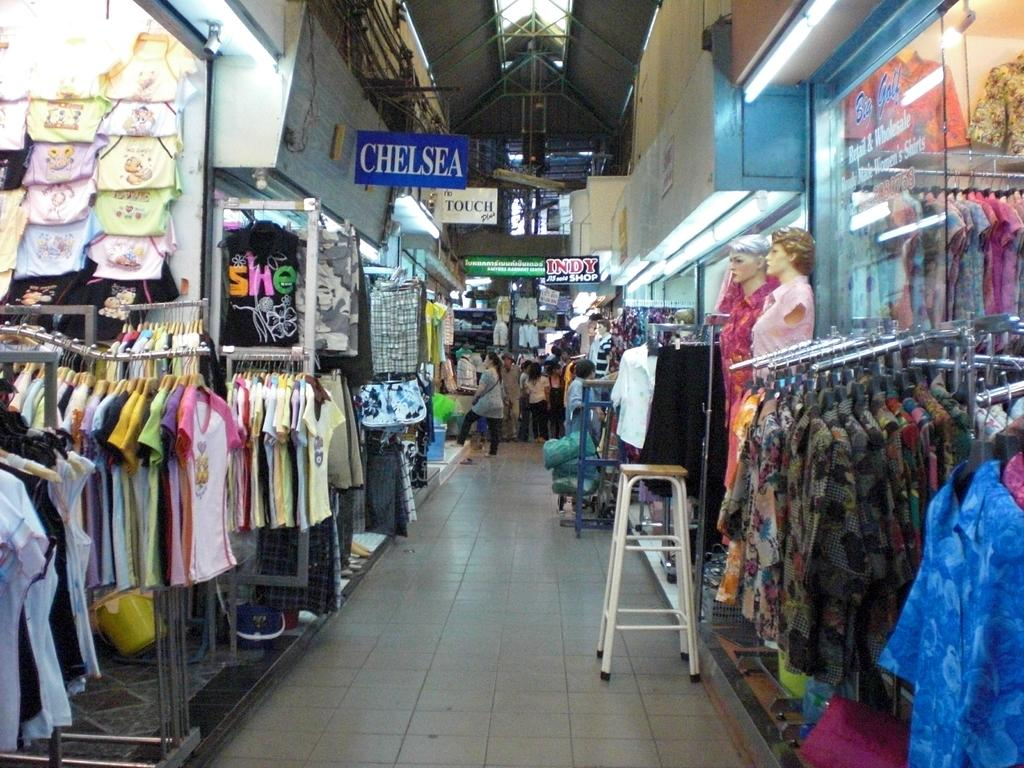Provide a one-sentence caption for the provided image. A long aisle of clothes with a Chelsea sign above them. 